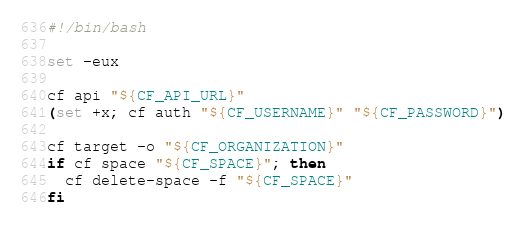<code> <loc_0><loc_0><loc_500><loc_500><_Bash_>#!/bin/bash

set -eux

cf api "${CF_API_URL}"
(set +x; cf auth "${CF_USERNAME}" "${CF_PASSWORD}")

cf target -o "${CF_ORGANIZATION}"
if cf space "${CF_SPACE}"; then
  cf delete-space -f "${CF_SPACE}"
fi
</code> 